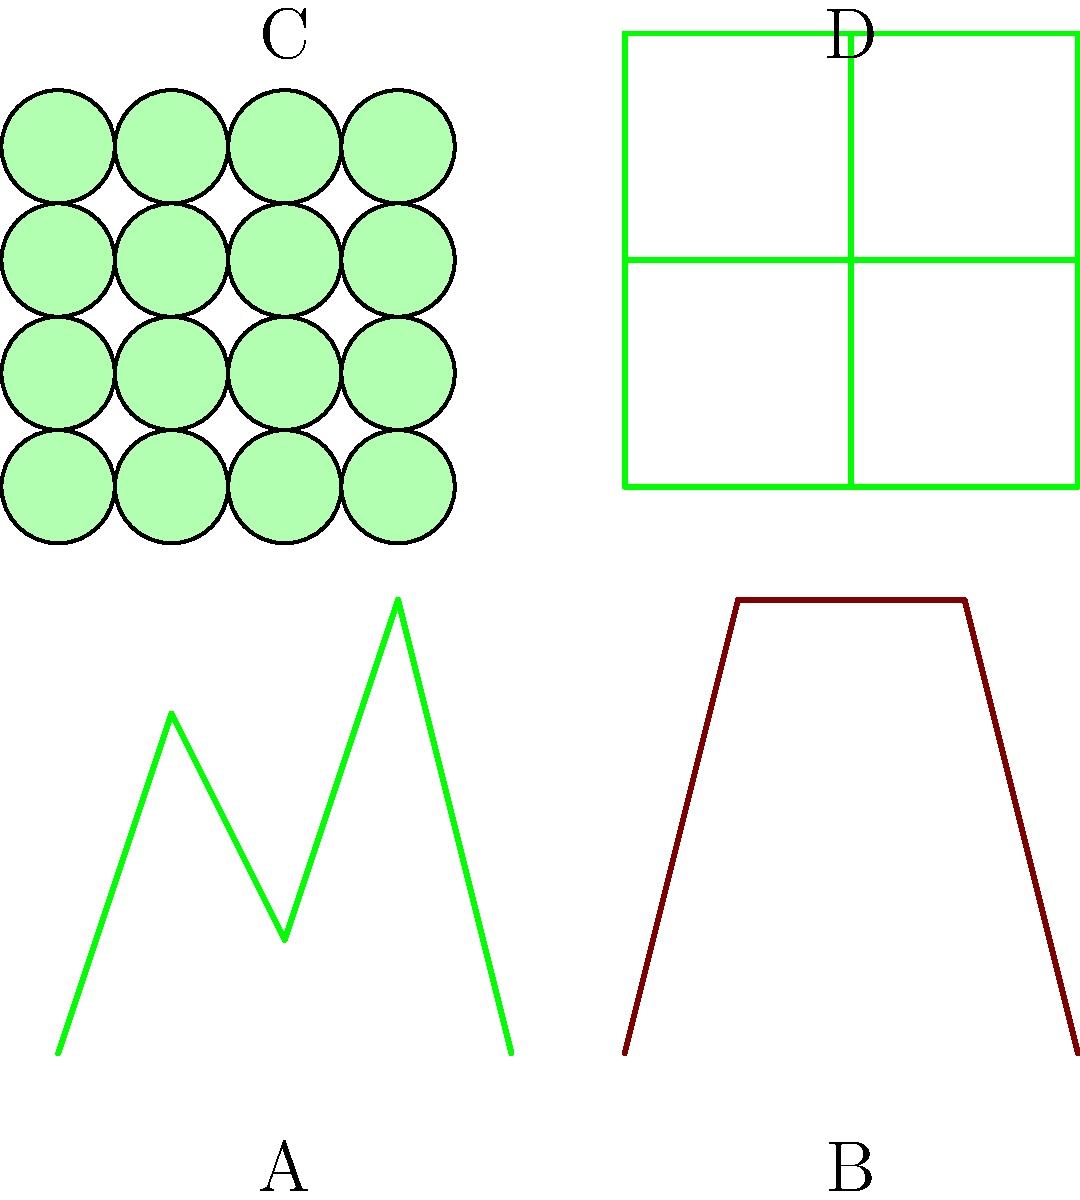As an experienced travel agent specializing in trips to Ireland, identify the landscape type represented in image C, which is commonly found in regions like Connemara and County Mayo. To identify the landscape type in image C, let's analyze each image:

1. Image A shows a series of peaks and valleys, representing mountainous terrain.
2. Image B depicts a flat top with steep sides, characteristic of coastal cliffs.
3. Image C displays a pattern of circular, interconnected shapes, which is typical of boglands or peatlands.
4. Image D shows a grid-like pattern, representing agricultural fields or pastures.

Given the question's focus on image C, we can deduce that this represents boglands or peatlands. This landscape is indeed common in regions like Connemara and County Mayo in Ireland.

Bogs are wetland ecosystems characterized by accumulations of peat, a layer of partially decayed vegetation matter. They are formed over thousands of years in areas with poor drainage and high rainfall, conditions that are prevalent in parts of Ireland.

The circular patterns in image C represent the typical surface features of a bog, including small pools of water and raised areas of vegetation. This aerial view captures the unique mosaic-like appearance of boglands, which is distinctly different from the other landscape types shown.

As an experienced travel agent specializing in Ireland, recognizing this landscape is crucial for planning itineraries that include visits to these unique and ecologically important areas, which are characteristic of certain regions in Ireland.
Answer: Boglands 